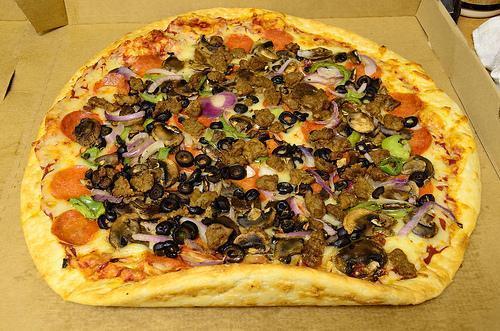How many pizzas are in the photo?
Give a very brief answer. 1. 